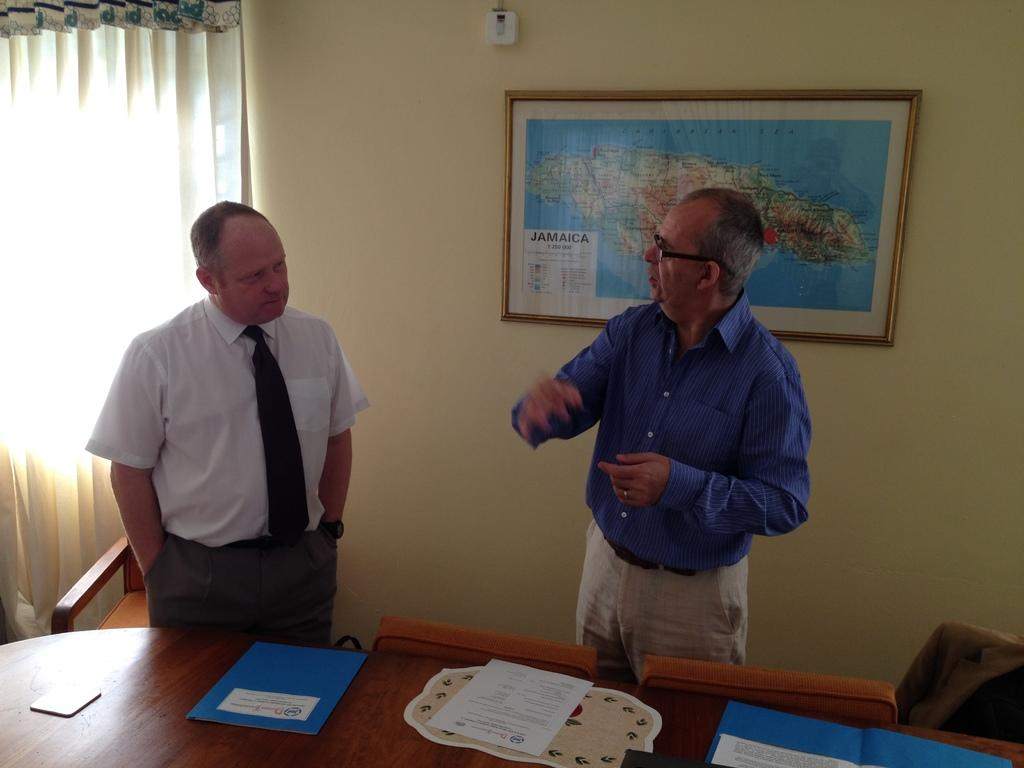How many people are in the image? There are two men in the image. What are the men doing in the image? The men are standing and talking. What can be seen on the wall behind the men? There is a world map on the wall behind the men. What is in front of the men? There is a table in front of the men. What is on the table? There are files on the table. When was the first man in the image born? The facts provided do not give any information about the birth of the men in the image, so it cannot be determined from the image. 